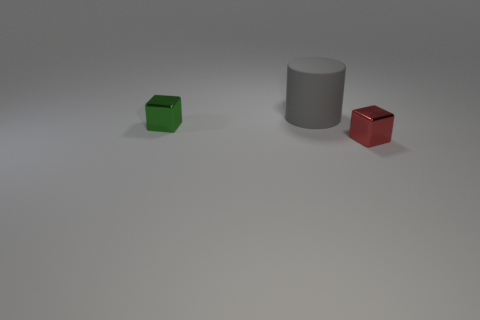Are there any other things that are the same size as the gray rubber cylinder?
Keep it short and to the point. No. Is there any other thing that has the same color as the large cylinder?
Keep it short and to the point. No. There is a small red metal thing in front of the gray rubber cylinder; is it the same shape as the tiny object behind the small red cube?
Offer a very short reply. Yes. Is there anything else that is the same material as the gray cylinder?
Provide a short and direct response. No. What is the shape of the metallic thing that is to the right of the tiny shiny thing behind the small object that is in front of the green metallic block?
Your response must be concise. Cube. What number of other objects are the same shape as the rubber thing?
Provide a succinct answer. 0. There is another shiny thing that is the same size as the green object; what is its color?
Give a very brief answer. Red. How many cylinders are either tiny metallic objects or tiny red objects?
Offer a very short reply. 0. How many red shiny blocks are there?
Offer a very short reply. 1. Do the green shiny object and the shiny thing to the right of the green block have the same shape?
Your response must be concise. Yes. 